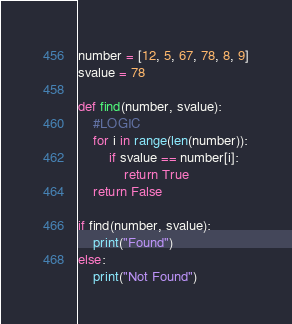Convert code to text. <code><loc_0><loc_0><loc_500><loc_500><_Python_>number = [12, 5, 67, 78, 8, 9]
svalue = 78

def find(number, svalue):
	#LOGIC
	for i in range(len(number)):
		if svalue == number[i]:
			return True
	return False

if find(number, svalue):
	print("Found")
else:
	print("Not Found")
</code> 